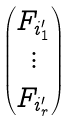<formula> <loc_0><loc_0><loc_500><loc_500>\begin{pmatrix} F _ { i _ { 1 } ^ { \prime } } \\ \vdots \\ F _ { i _ { r } ^ { \prime } } \end{pmatrix}</formula> 